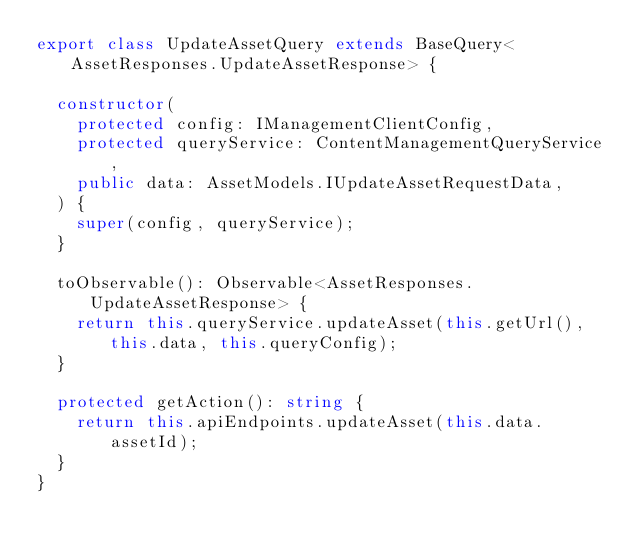<code> <loc_0><loc_0><loc_500><loc_500><_TypeScript_>export class UpdateAssetQuery extends BaseQuery<AssetResponses.UpdateAssetResponse> {

  constructor(
    protected config: IManagementClientConfig,
    protected queryService: ContentManagementQueryService,
    public data: AssetModels.IUpdateAssetRequestData,
  ) {
    super(config, queryService);
  }

  toObservable(): Observable<AssetResponses.UpdateAssetResponse> {
    return this.queryService.updateAsset(this.getUrl(), this.data, this.queryConfig);
  }

  protected getAction(): string {
    return this.apiEndpoints.updateAsset(this.data.assetId);
  }
}


</code> 